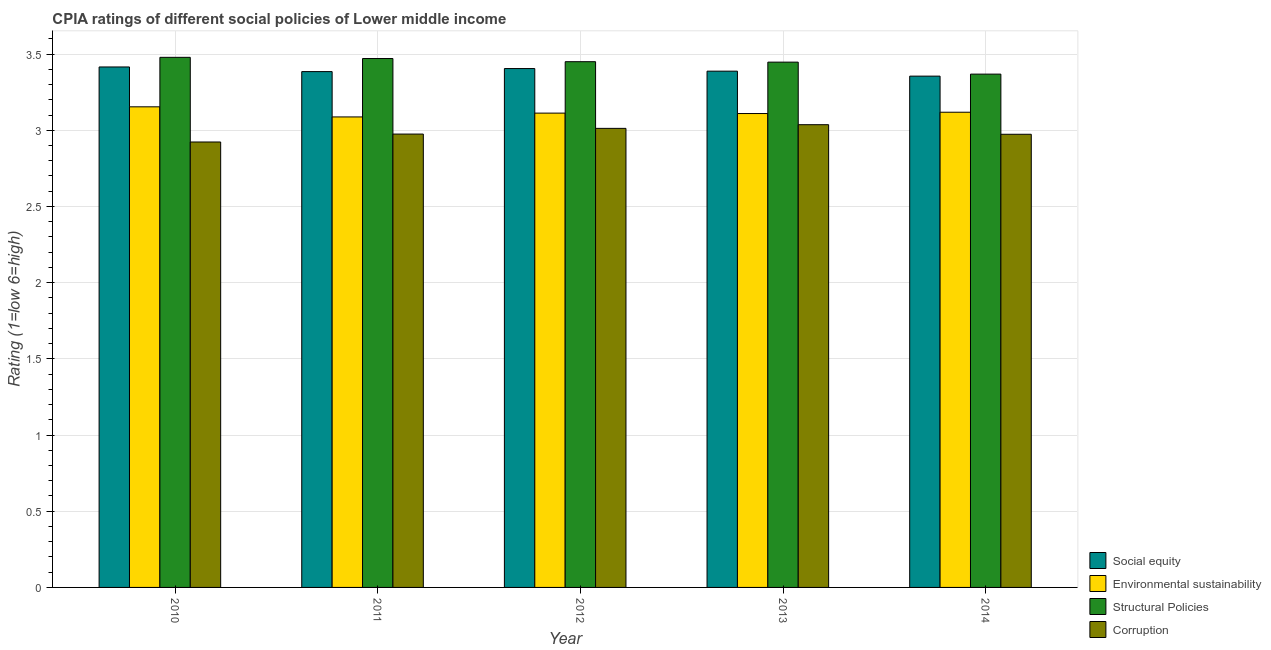How many different coloured bars are there?
Your response must be concise. 4. What is the label of the 4th group of bars from the left?
Your answer should be very brief. 2013. What is the cpia rating of corruption in 2013?
Your answer should be compact. 3.04. Across all years, what is the maximum cpia rating of environmental sustainability?
Your response must be concise. 3.15. Across all years, what is the minimum cpia rating of social equity?
Make the answer very short. 3.36. What is the total cpia rating of corruption in the graph?
Ensure brevity in your answer.  14.92. What is the difference between the cpia rating of corruption in 2011 and that in 2014?
Provide a succinct answer. 0. What is the difference between the cpia rating of corruption in 2010 and the cpia rating of environmental sustainability in 2011?
Your response must be concise. -0.05. What is the average cpia rating of environmental sustainability per year?
Offer a terse response. 3.12. In the year 2013, what is the difference between the cpia rating of social equity and cpia rating of structural policies?
Provide a short and direct response. 0. In how many years, is the cpia rating of corruption greater than 0.2?
Your answer should be very brief. 5. What is the ratio of the cpia rating of corruption in 2012 to that in 2014?
Offer a terse response. 1.01. Is the difference between the cpia rating of corruption in 2010 and 2011 greater than the difference between the cpia rating of environmental sustainability in 2010 and 2011?
Provide a succinct answer. No. What is the difference between the highest and the second highest cpia rating of environmental sustainability?
Give a very brief answer. 0.04. What is the difference between the highest and the lowest cpia rating of social equity?
Offer a very short reply. 0.06. Is it the case that in every year, the sum of the cpia rating of structural policies and cpia rating of social equity is greater than the sum of cpia rating of corruption and cpia rating of environmental sustainability?
Make the answer very short. Yes. What does the 1st bar from the left in 2012 represents?
Provide a succinct answer. Social equity. What does the 3rd bar from the right in 2014 represents?
Ensure brevity in your answer.  Environmental sustainability. How many bars are there?
Your response must be concise. 20. Are all the bars in the graph horizontal?
Make the answer very short. No. How many years are there in the graph?
Your response must be concise. 5. What is the difference between two consecutive major ticks on the Y-axis?
Offer a very short reply. 0.5. Does the graph contain any zero values?
Give a very brief answer. No. What is the title of the graph?
Your answer should be compact. CPIA ratings of different social policies of Lower middle income. What is the label or title of the X-axis?
Make the answer very short. Year. What is the label or title of the Y-axis?
Your answer should be very brief. Rating (1=low 6=high). What is the Rating (1=low 6=high) of Social equity in 2010?
Offer a very short reply. 3.42. What is the Rating (1=low 6=high) in Environmental sustainability in 2010?
Your response must be concise. 3.15. What is the Rating (1=low 6=high) in Structural Policies in 2010?
Provide a succinct answer. 3.48. What is the Rating (1=low 6=high) of Corruption in 2010?
Provide a short and direct response. 2.92. What is the Rating (1=low 6=high) in Social equity in 2011?
Provide a short and direct response. 3.38. What is the Rating (1=low 6=high) in Environmental sustainability in 2011?
Keep it short and to the point. 3.09. What is the Rating (1=low 6=high) in Structural Policies in 2011?
Your answer should be very brief. 3.47. What is the Rating (1=low 6=high) of Corruption in 2011?
Offer a terse response. 2.98. What is the Rating (1=low 6=high) of Social equity in 2012?
Provide a short and direct response. 3.4. What is the Rating (1=low 6=high) in Environmental sustainability in 2012?
Give a very brief answer. 3.11. What is the Rating (1=low 6=high) in Structural Policies in 2012?
Make the answer very short. 3.45. What is the Rating (1=low 6=high) in Corruption in 2012?
Offer a terse response. 3.01. What is the Rating (1=low 6=high) in Social equity in 2013?
Ensure brevity in your answer.  3.39. What is the Rating (1=low 6=high) in Environmental sustainability in 2013?
Offer a very short reply. 3.11. What is the Rating (1=low 6=high) of Structural Policies in 2013?
Make the answer very short. 3.45. What is the Rating (1=low 6=high) of Corruption in 2013?
Your answer should be very brief. 3.04. What is the Rating (1=low 6=high) in Social equity in 2014?
Ensure brevity in your answer.  3.36. What is the Rating (1=low 6=high) in Environmental sustainability in 2014?
Your response must be concise. 3.12. What is the Rating (1=low 6=high) in Structural Policies in 2014?
Offer a very short reply. 3.37. What is the Rating (1=low 6=high) in Corruption in 2014?
Provide a succinct answer. 2.97. Across all years, what is the maximum Rating (1=low 6=high) in Social equity?
Your answer should be compact. 3.42. Across all years, what is the maximum Rating (1=low 6=high) in Environmental sustainability?
Provide a short and direct response. 3.15. Across all years, what is the maximum Rating (1=low 6=high) of Structural Policies?
Give a very brief answer. 3.48. Across all years, what is the maximum Rating (1=low 6=high) of Corruption?
Offer a terse response. 3.04. Across all years, what is the minimum Rating (1=low 6=high) of Social equity?
Provide a succinct answer. 3.36. Across all years, what is the minimum Rating (1=low 6=high) in Environmental sustainability?
Offer a terse response. 3.09. Across all years, what is the minimum Rating (1=low 6=high) in Structural Policies?
Ensure brevity in your answer.  3.37. Across all years, what is the minimum Rating (1=low 6=high) in Corruption?
Your answer should be compact. 2.92. What is the total Rating (1=low 6=high) in Social equity in the graph?
Offer a terse response. 16.95. What is the total Rating (1=low 6=high) in Environmental sustainability in the graph?
Keep it short and to the point. 15.58. What is the total Rating (1=low 6=high) of Structural Policies in the graph?
Make the answer very short. 17.21. What is the total Rating (1=low 6=high) in Corruption in the graph?
Your answer should be compact. 14.92. What is the difference between the Rating (1=low 6=high) in Social equity in 2010 and that in 2011?
Provide a succinct answer. 0.03. What is the difference between the Rating (1=low 6=high) in Environmental sustainability in 2010 and that in 2011?
Your response must be concise. 0.07. What is the difference between the Rating (1=low 6=high) of Structural Policies in 2010 and that in 2011?
Offer a terse response. 0.01. What is the difference between the Rating (1=low 6=high) of Corruption in 2010 and that in 2011?
Your response must be concise. -0.05. What is the difference between the Rating (1=low 6=high) in Social equity in 2010 and that in 2012?
Provide a succinct answer. 0.01. What is the difference between the Rating (1=low 6=high) of Environmental sustainability in 2010 and that in 2012?
Keep it short and to the point. 0.04. What is the difference between the Rating (1=low 6=high) in Structural Policies in 2010 and that in 2012?
Your response must be concise. 0.03. What is the difference between the Rating (1=low 6=high) in Corruption in 2010 and that in 2012?
Offer a very short reply. -0.09. What is the difference between the Rating (1=low 6=high) of Social equity in 2010 and that in 2013?
Offer a very short reply. 0.03. What is the difference between the Rating (1=low 6=high) of Environmental sustainability in 2010 and that in 2013?
Make the answer very short. 0.04. What is the difference between the Rating (1=low 6=high) of Structural Policies in 2010 and that in 2013?
Your response must be concise. 0.03. What is the difference between the Rating (1=low 6=high) in Corruption in 2010 and that in 2013?
Offer a very short reply. -0.11. What is the difference between the Rating (1=low 6=high) of Social equity in 2010 and that in 2014?
Your response must be concise. 0.06. What is the difference between the Rating (1=low 6=high) of Environmental sustainability in 2010 and that in 2014?
Ensure brevity in your answer.  0.04. What is the difference between the Rating (1=low 6=high) in Structural Policies in 2010 and that in 2014?
Give a very brief answer. 0.11. What is the difference between the Rating (1=low 6=high) in Corruption in 2010 and that in 2014?
Your response must be concise. -0.05. What is the difference between the Rating (1=low 6=high) of Social equity in 2011 and that in 2012?
Ensure brevity in your answer.  -0.02. What is the difference between the Rating (1=low 6=high) in Environmental sustainability in 2011 and that in 2012?
Provide a succinct answer. -0.03. What is the difference between the Rating (1=low 6=high) in Structural Policies in 2011 and that in 2012?
Offer a very short reply. 0.02. What is the difference between the Rating (1=low 6=high) in Corruption in 2011 and that in 2012?
Your response must be concise. -0.04. What is the difference between the Rating (1=low 6=high) of Social equity in 2011 and that in 2013?
Your answer should be very brief. -0. What is the difference between the Rating (1=low 6=high) in Environmental sustainability in 2011 and that in 2013?
Keep it short and to the point. -0.02. What is the difference between the Rating (1=low 6=high) in Structural Policies in 2011 and that in 2013?
Your response must be concise. 0.02. What is the difference between the Rating (1=low 6=high) of Corruption in 2011 and that in 2013?
Your answer should be compact. -0.06. What is the difference between the Rating (1=low 6=high) of Social equity in 2011 and that in 2014?
Offer a terse response. 0.03. What is the difference between the Rating (1=low 6=high) in Environmental sustainability in 2011 and that in 2014?
Your response must be concise. -0.03. What is the difference between the Rating (1=low 6=high) in Structural Policies in 2011 and that in 2014?
Offer a very short reply. 0.1. What is the difference between the Rating (1=low 6=high) of Corruption in 2011 and that in 2014?
Ensure brevity in your answer.  0. What is the difference between the Rating (1=low 6=high) in Social equity in 2012 and that in 2013?
Offer a terse response. 0.02. What is the difference between the Rating (1=low 6=high) in Environmental sustainability in 2012 and that in 2013?
Your answer should be compact. 0. What is the difference between the Rating (1=low 6=high) in Structural Policies in 2012 and that in 2013?
Ensure brevity in your answer.  0. What is the difference between the Rating (1=low 6=high) in Corruption in 2012 and that in 2013?
Provide a short and direct response. -0.02. What is the difference between the Rating (1=low 6=high) of Social equity in 2012 and that in 2014?
Keep it short and to the point. 0.05. What is the difference between the Rating (1=low 6=high) in Environmental sustainability in 2012 and that in 2014?
Provide a short and direct response. -0.01. What is the difference between the Rating (1=low 6=high) in Structural Policies in 2012 and that in 2014?
Ensure brevity in your answer.  0.08. What is the difference between the Rating (1=low 6=high) of Corruption in 2012 and that in 2014?
Offer a very short reply. 0.04. What is the difference between the Rating (1=low 6=high) of Social equity in 2013 and that in 2014?
Offer a very short reply. 0.03. What is the difference between the Rating (1=low 6=high) of Environmental sustainability in 2013 and that in 2014?
Your response must be concise. -0.01. What is the difference between the Rating (1=low 6=high) of Structural Policies in 2013 and that in 2014?
Give a very brief answer. 0.08. What is the difference between the Rating (1=low 6=high) of Corruption in 2013 and that in 2014?
Your answer should be very brief. 0.06. What is the difference between the Rating (1=low 6=high) in Social equity in 2010 and the Rating (1=low 6=high) in Environmental sustainability in 2011?
Your response must be concise. 0.33. What is the difference between the Rating (1=low 6=high) of Social equity in 2010 and the Rating (1=low 6=high) of Structural Policies in 2011?
Your answer should be very brief. -0.06. What is the difference between the Rating (1=low 6=high) in Social equity in 2010 and the Rating (1=low 6=high) in Corruption in 2011?
Your answer should be very brief. 0.44. What is the difference between the Rating (1=low 6=high) of Environmental sustainability in 2010 and the Rating (1=low 6=high) of Structural Policies in 2011?
Your answer should be very brief. -0.32. What is the difference between the Rating (1=low 6=high) in Environmental sustainability in 2010 and the Rating (1=low 6=high) in Corruption in 2011?
Ensure brevity in your answer.  0.18. What is the difference between the Rating (1=low 6=high) in Structural Policies in 2010 and the Rating (1=low 6=high) in Corruption in 2011?
Make the answer very short. 0.5. What is the difference between the Rating (1=low 6=high) in Social equity in 2010 and the Rating (1=low 6=high) in Environmental sustainability in 2012?
Offer a very short reply. 0.3. What is the difference between the Rating (1=low 6=high) in Social equity in 2010 and the Rating (1=low 6=high) in Structural Policies in 2012?
Provide a short and direct response. -0.03. What is the difference between the Rating (1=low 6=high) in Social equity in 2010 and the Rating (1=low 6=high) in Corruption in 2012?
Your answer should be compact. 0.4. What is the difference between the Rating (1=low 6=high) in Environmental sustainability in 2010 and the Rating (1=low 6=high) in Structural Policies in 2012?
Ensure brevity in your answer.  -0.3. What is the difference between the Rating (1=low 6=high) in Environmental sustainability in 2010 and the Rating (1=low 6=high) in Corruption in 2012?
Make the answer very short. 0.14. What is the difference between the Rating (1=low 6=high) in Structural Policies in 2010 and the Rating (1=low 6=high) in Corruption in 2012?
Offer a terse response. 0.47. What is the difference between the Rating (1=low 6=high) in Social equity in 2010 and the Rating (1=low 6=high) in Environmental sustainability in 2013?
Your answer should be compact. 0.31. What is the difference between the Rating (1=low 6=high) in Social equity in 2010 and the Rating (1=low 6=high) in Structural Policies in 2013?
Your response must be concise. -0.03. What is the difference between the Rating (1=low 6=high) in Social equity in 2010 and the Rating (1=low 6=high) in Corruption in 2013?
Your response must be concise. 0.38. What is the difference between the Rating (1=low 6=high) in Environmental sustainability in 2010 and the Rating (1=low 6=high) in Structural Policies in 2013?
Your answer should be compact. -0.29. What is the difference between the Rating (1=low 6=high) in Environmental sustainability in 2010 and the Rating (1=low 6=high) in Corruption in 2013?
Your answer should be compact. 0.12. What is the difference between the Rating (1=low 6=high) in Structural Policies in 2010 and the Rating (1=low 6=high) in Corruption in 2013?
Your answer should be compact. 0.44. What is the difference between the Rating (1=low 6=high) in Social equity in 2010 and the Rating (1=low 6=high) in Environmental sustainability in 2014?
Ensure brevity in your answer.  0.3. What is the difference between the Rating (1=low 6=high) of Social equity in 2010 and the Rating (1=low 6=high) of Structural Policies in 2014?
Your response must be concise. 0.05. What is the difference between the Rating (1=low 6=high) of Social equity in 2010 and the Rating (1=low 6=high) of Corruption in 2014?
Your answer should be compact. 0.44. What is the difference between the Rating (1=low 6=high) of Environmental sustainability in 2010 and the Rating (1=low 6=high) of Structural Policies in 2014?
Offer a very short reply. -0.21. What is the difference between the Rating (1=low 6=high) in Environmental sustainability in 2010 and the Rating (1=low 6=high) in Corruption in 2014?
Your response must be concise. 0.18. What is the difference between the Rating (1=low 6=high) of Structural Policies in 2010 and the Rating (1=low 6=high) of Corruption in 2014?
Give a very brief answer. 0.5. What is the difference between the Rating (1=low 6=high) of Social equity in 2011 and the Rating (1=low 6=high) of Environmental sustainability in 2012?
Make the answer very short. 0.27. What is the difference between the Rating (1=low 6=high) of Social equity in 2011 and the Rating (1=low 6=high) of Structural Policies in 2012?
Your answer should be compact. -0.07. What is the difference between the Rating (1=low 6=high) in Social equity in 2011 and the Rating (1=low 6=high) in Corruption in 2012?
Ensure brevity in your answer.  0.37. What is the difference between the Rating (1=low 6=high) in Environmental sustainability in 2011 and the Rating (1=low 6=high) in Structural Policies in 2012?
Your response must be concise. -0.36. What is the difference between the Rating (1=low 6=high) in Environmental sustainability in 2011 and the Rating (1=low 6=high) in Corruption in 2012?
Give a very brief answer. 0.07. What is the difference between the Rating (1=low 6=high) in Structural Policies in 2011 and the Rating (1=low 6=high) in Corruption in 2012?
Offer a very short reply. 0.46. What is the difference between the Rating (1=low 6=high) in Social equity in 2011 and the Rating (1=low 6=high) in Environmental sustainability in 2013?
Offer a very short reply. 0.28. What is the difference between the Rating (1=low 6=high) in Social equity in 2011 and the Rating (1=low 6=high) in Structural Policies in 2013?
Your answer should be compact. -0.06. What is the difference between the Rating (1=low 6=high) in Social equity in 2011 and the Rating (1=low 6=high) in Corruption in 2013?
Your answer should be very brief. 0.35. What is the difference between the Rating (1=low 6=high) of Environmental sustainability in 2011 and the Rating (1=low 6=high) of Structural Policies in 2013?
Your response must be concise. -0.36. What is the difference between the Rating (1=low 6=high) in Environmental sustainability in 2011 and the Rating (1=low 6=high) in Corruption in 2013?
Offer a very short reply. 0.05. What is the difference between the Rating (1=low 6=high) in Structural Policies in 2011 and the Rating (1=low 6=high) in Corruption in 2013?
Your answer should be very brief. 0.43. What is the difference between the Rating (1=low 6=high) of Social equity in 2011 and the Rating (1=low 6=high) of Environmental sustainability in 2014?
Offer a very short reply. 0.27. What is the difference between the Rating (1=low 6=high) in Social equity in 2011 and the Rating (1=low 6=high) in Structural Policies in 2014?
Provide a short and direct response. 0.02. What is the difference between the Rating (1=low 6=high) of Social equity in 2011 and the Rating (1=low 6=high) of Corruption in 2014?
Keep it short and to the point. 0.41. What is the difference between the Rating (1=low 6=high) of Environmental sustainability in 2011 and the Rating (1=low 6=high) of Structural Policies in 2014?
Offer a very short reply. -0.28. What is the difference between the Rating (1=low 6=high) in Environmental sustainability in 2011 and the Rating (1=low 6=high) in Corruption in 2014?
Provide a short and direct response. 0.11. What is the difference between the Rating (1=low 6=high) in Structural Policies in 2011 and the Rating (1=low 6=high) in Corruption in 2014?
Offer a terse response. 0.5. What is the difference between the Rating (1=low 6=high) in Social equity in 2012 and the Rating (1=low 6=high) in Environmental sustainability in 2013?
Offer a very short reply. 0.3. What is the difference between the Rating (1=low 6=high) of Social equity in 2012 and the Rating (1=low 6=high) of Structural Policies in 2013?
Offer a terse response. -0.04. What is the difference between the Rating (1=low 6=high) in Social equity in 2012 and the Rating (1=low 6=high) in Corruption in 2013?
Your response must be concise. 0.37. What is the difference between the Rating (1=low 6=high) in Environmental sustainability in 2012 and the Rating (1=low 6=high) in Structural Policies in 2013?
Provide a short and direct response. -0.33. What is the difference between the Rating (1=low 6=high) of Environmental sustainability in 2012 and the Rating (1=low 6=high) of Corruption in 2013?
Make the answer very short. 0.08. What is the difference between the Rating (1=low 6=high) of Structural Policies in 2012 and the Rating (1=low 6=high) of Corruption in 2013?
Your response must be concise. 0.41. What is the difference between the Rating (1=low 6=high) of Social equity in 2012 and the Rating (1=low 6=high) of Environmental sustainability in 2014?
Offer a very short reply. 0.29. What is the difference between the Rating (1=low 6=high) of Social equity in 2012 and the Rating (1=low 6=high) of Structural Policies in 2014?
Give a very brief answer. 0.04. What is the difference between the Rating (1=low 6=high) in Social equity in 2012 and the Rating (1=low 6=high) in Corruption in 2014?
Offer a very short reply. 0.43. What is the difference between the Rating (1=low 6=high) of Environmental sustainability in 2012 and the Rating (1=low 6=high) of Structural Policies in 2014?
Your answer should be compact. -0.26. What is the difference between the Rating (1=low 6=high) of Environmental sustainability in 2012 and the Rating (1=low 6=high) of Corruption in 2014?
Keep it short and to the point. 0.14. What is the difference between the Rating (1=low 6=high) in Structural Policies in 2012 and the Rating (1=low 6=high) in Corruption in 2014?
Make the answer very short. 0.48. What is the difference between the Rating (1=low 6=high) in Social equity in 2013 and the Rating (1=low 6=high) in Environmental sustainability in 2014?
Your answer should be very brief. 0.27. What is the difference between the Rating (1=low 6=high) of Social equity in 2013 and the Rating (1=low 6=high) of Structural Policies in 2014?
Provide a short and direct response. 0.02. What is the difference between the Rating (1=low 6=high) in Social equity in 2013 and the Rating (1=low 6=high) in Corruption in 2014?
Provide a short and direct response. 0.41. What is the difference between the Rating (1=low 6=high) of Environmental sustainability in 2013 and the Rating (1=low 6=high) of Structural Policies in 2014?
Your answer should be compact. -0.26. What is the difference between the Rating (1=low 6=high) in Environmental sustainability in 2013 and the Rating (1=low 6=high) in Corruption in 2014?
Offer a very short reply. 0.14. What is the difference between the Rating (1=low 6=high) of Structural Policies in 2013 and the Rating (1=low 6=high) of Corruption in 2014?
Your answer should be compact. 0.47. What is the average Rating (1=low 6=high) of Social equity per year?
Give a very brief answer. 3.39. What is the average Rating (1=low 6=high) of Environmental sustainability per year?
Provide a succinct answer. 3.12. What is the average Rating (1=low 6=high) in Structural Policies per year?
Offer a very short reply. 3.44. What is the average Rating (1=low 6=high) of Corruption per year?
Provide a succinct answer. 2.98. In the year 2010, what is the difference between the Rating (1=low 6=high) of Social equity and Rating (1=low 6=high) of Environmental sustainability?
Offer a very short reply. 0.26. In the year 2010, what is the difference between the Rating (1=low 6=high) of Social equity and Rating (1=low 6=high) of Structural Policies?
Provide a short and direct response. -0.06. In the year 2010, what is the difference between the Rating (1=low 6=high) of Social equity and Rating (1=low 6=high) of Corruption?
Your answer should be compact. 0.49. In the year 2010, what is the difference between the Rating (1=low 6=high) in Environmental sustainability and Rating (1=low 6=high) in Structural Policies?
Offer a terse response. -0.32. In the year 2010, what is the difference between the Rating (1=low 6=high) of Environmental sustainability and Rating (1=low 6=high) of Corruption?
Make the answer very short. 0.23. In the year 2010, what is the difference between the Rating (1=low 6=high) in Structural Policies and Rating (1=low 6=high) in Corruption?
Your answer should be very brief. 0.56. In the year 2011, what is the difference between the Rating (1=low 6=high) of Social equity and Rating (1=low 6=high) of Environmental sustainability?
Your answer should be compact. 0.3. In the year 2011, what is the difference between the Rating (1=low 6=high) in Social equity and Rating (1=low 6=high) in Structural Policies?
Offer a very short reply. -0.09. In the year 2011, what is the difference between the Rating (1=low 6=high) of Social equity and Rating (1=low 6=high) of Corruption?
Your response must be concise. 0.41. In the year 2011, what is the difference between the Rating (1=low 6=high) in Environmental sustainability and Rating (1=low 6=high) in Structural Policies?
Offer a terse response. -0.38. In the year 2011, what is the difference between the Rating (1=low 6=high) in Environmental sustainability and Rating (1=low 6=high) in Corruption?
Your response must be concise. 0.11. In the year 2011, what is the difference between the Rating (1=low 6=high) in Structural Policies and Rating (1=low 6=high) in Corruption?
Offer a very short reply. 0.5. In the year 2012, what is the difference between the Rating (1=low 6=high) of Social equity and Rating (1=low 6=high) of Environmental sustainability?
Keep it short and to the point. 0.29. In the year 2012, what is the difference between the Rating (1=low 6=high) in Social equity and Rating (1=low 6=high) in Structural Policies?
Offer a terse response. -0.04. In the year 2012, what is the difference between the Rating (1=low 6=high) of Social equity and Rating (1=low 6=high) of Corruption?
Offer a very short reply. 0.39. In the year 2012, what is the difference between the Rating (1=low 6=high) of Environmental sustainability and Rating (1=low 6=high) of Structural Policies?
Provide a short and direct response. -0.34. In the year 2012, what is the difference between the Rating (1=low 6=high) of Environmental sustainability and Rating (1=low 6=high) of Corruption?
Keep it short and to the point. 0.1. In the year 2012, what is the difference between the Rating (1=low 6=high) in Structural Policies and Rating (1=low 6=high) in Corruption?
Provide a succinct answer. 0.44. In the year 2013, what is the difference between the Rating (1=low 6=high) in Social equity and Rating (1=low 6=high) in Environmental sustainability?
Your answer should be very brief. 0.28. In the year 2013, what is the difference between the Rating (1=low 6=high) of Social equity and Rating (1=low 6=high) of Structural Policies?
Give a very brief answer. -0.06. In the year 2013, what is the difference between the Rating (1=low 6=high) in Social equity and Rating (1=low 6=high) in Corruption?
Keep it short and to the point. 0.35. In the year 2013, what is the difference between the Rating (1=low 6=high) of Environmental sustainability and Rating (1=low 6=high) of Structural Policies?
Your answer should be very brief. -0.34. In the year 2013, what is the difference between the Rating (1=low 6=high) in Environmental sustainability and Rating (1=low 6=high) in Corruption?
Ensure brevity in your answer.  0.07. In the year 2013, what is the difference between the Rating (1=low 6=high) of Structural Policies and Rating (1=low 6=high) of Corruption?
Ensure brevity in your answer.  0.41. In the year 2014, what is the difference between the Rating (1=low 6=high) in Social equity and Rating (1=low 6=high) in Environmental sustainability?
Keep it short and to the point. 0.24. In the year 2014, what is the difference between the Rating (1=low 6=high) in Social equity and Rating (1=low 6=high) in Structural Policies?
Offer a very short reply. -0.01. In the year 2014, what is the difference between the Rating (1=low 6=high) in Social equity and Rating (1=low 6=high) in Corruption?
Ensure brevity in your answer.  0.38. In the year 2014, what is the difference between the Rating (1=low 6=high) in Environmental sustainability and Rating (1=low 6=high) in Corruption?
Provide a short and direct response. 0.14. In the year 2014, what is the difference between the Rating (1=low 6=high) of Structural Policies and Rating (1=low 6=high) of Corruption?
Ensure brevity in your answer.  0.39. What is the ratio of the Rating (1=low 6=high) of Environmental sustainability in 2010 to that in 2011?
Your answer should be compact. 1.02. What is the ratio of the Rating (1=low 6=high) in Structural Policies in 2010 to that in 2011?
Provide a succinct answer. 1. What is the ratio of the Rating (1=low 6=high) of Corruption in 2010 to that in 2011?
Keep it short and to the point. 0.98. What is the ratio of the Rating (1=low 6=high) of Social equity in 2010 to that in 2012?
Offer a terse response. 1. What is the ratio of the Rating (1=low 6=high) in Environmental sustainability in 2010 to that in 2012?
Ensure brevity in your answer.  1.01. What is the ratio of the Rating (1=low 6=high) of Structural Policies in 2010 to that in 2012?
Your answer should be very brief. 1.01. What is the ratio of the Rating (1=low 6=high) of Corruption in 2010 to that in 2012?
Provide a succinct answer. 0.97. What is the ratio of the Rating (1=low 6=high) of Environmental sustainability in 2010 to that in 2013?
Offer a very short reply. 1.01. What is the ratio of the Rating (1=low 6=high) of Structural Policies in 2010 to that in 2013?
Ensure brevity in your answer.  1.01. What is the ratio of the Rating (1=low 6=high) of Corruption in 2010 to that in 2013?
Offer a terse response. 0.96. What is the ratio of the Rating (1=low 6=high) of Social equity in 2010 to that in 2014?
Make the answer very short. 1.02. What is the ratio of the Rating (1=low 6=high) of Environmental sustainability in 2010 to that in 2014?
Provide a short and direct response. 1.01. What is the ratio of the Rating (1=low 6=high) in Structural Policies in 2010 to that in 2014?
Your answer should be very brief. 1.03. What is the ratio of the Rating (1=low 6=high) of Corruption in 2010 to that in 2014?
Provide a short and direct response. 0.98. What is the ratio of the Rating (1=low 6=high) of Social equity in 2011 to that in 2012?
Ensure brevity in your answer.  0.99. What is the ratio of the Rating (1=low 6=high) in Environmental sustainability in 2011 to that in 2012?
Keep it short and to the point. 0.99. What is the ratio of the Rating (1=low 6=high) in Corruption in 2011 to that in 2012?
Your answer should be compact. 0.99. What is the ratio of the Rating (1=low 6=high) of Social equity in 2011 to that in 2013?
Provide a succinct answer. 1. What is the ratio of the Rating (1=low 6=high) of Structural Policies in 2011 to that in 2013?
Your answer should be very brief. 1.01. What is the ratio of the Rating (1=low 6=high) of Corruption in 2011 to that in 2013?
Provide a succinct answer. 0.98. What is the ratio of the Rating (1=low 6=high) in Social equity in 2011 to that in 2014?
Offer a very short reply. 1.01. What is the ratio of the Rating (1=low 6=high) in Structural Policies in 2011 to that in 2014?
Keep it short and to the point. 1.03. What is the ratio of the Rating (1=low 6=high) in Social equity in 2012 to that in 2013?
Your answer should be very brief. 1.01. What is the ratio of the Rating (1=low 6=high) in Structural Policies in 2012 to that in 2013?
Keep it short and to the point. 1. What is the ratio of the Rating (1=low 6=high) in Corruption in 2012 to that in 2013?
Offer a terse response. 0.99. What is the ratio of the Rating (1=low 6=high) in Social equity in 2012 to that in 2014?
Give a very brief answer. 1.01. What is the ratio of the Rating (1=low 6=high) of Structural Policies in 2012 to that in 2014?
Keep it short and to the point. 1.02. What is the ratio of the Rating (1=low 6=high) of Corruption in 2012 to that in 2014?
Provide a short and direct response. 1.01. What is the ratio of the Rating (1=low 6=high) of Social equity in 2013 to that in 2014?
Make the answer very short. 1.01. What is the ratio of the Rating (1=low 6=high) of Environmental sustainability in 2013 to that in 2014?
Your response must be concise. 1. What is the ratio of the Rating (1=low 6=high) in Structural Policies in 2013 to that in 2014?
Offer a very short reply. 1.02. What is the ratio of the Rating (1=low 6=high) of Corruption in 2013 to that in 2014?
Provide a succinct answer. 1.02. What is the difference between the highest and the second highest Rating (1=low 6=high) of Social equity?
Make the answer very short. 0.01. What is the difference between the highest and the second highest Rating (1=low 6=high) in Environmental sustainability?
Provide a succinct answer. 0.04. What is the difference between the highest and the second highest Rating (1=low 6=high) of Structural Policies?
Provide a short and direct response. 0.01. What is the difference between the highest and the second highest Rating (1=low 6=high) in Corruption?
Give a very brief answer. 0.02. What is the difference between the highest and the lowest Rating (1=low 6=high) in Social equity?
Your answer should be compact. 0.06. What is the difference between the highest and the lowest Rating (1=low 6=high) of Environmental sustainability?
Your answer should be very brief. 0.07. What is the difference between the highest and the lowest Rating (1=low 6=high) of Structural Policies?
Your answer should be compact. 0.11. What is the difference between the highest and the lowest Rating (1=low 6=high) of Corruption?
Offer a very short reply. 0.11. 